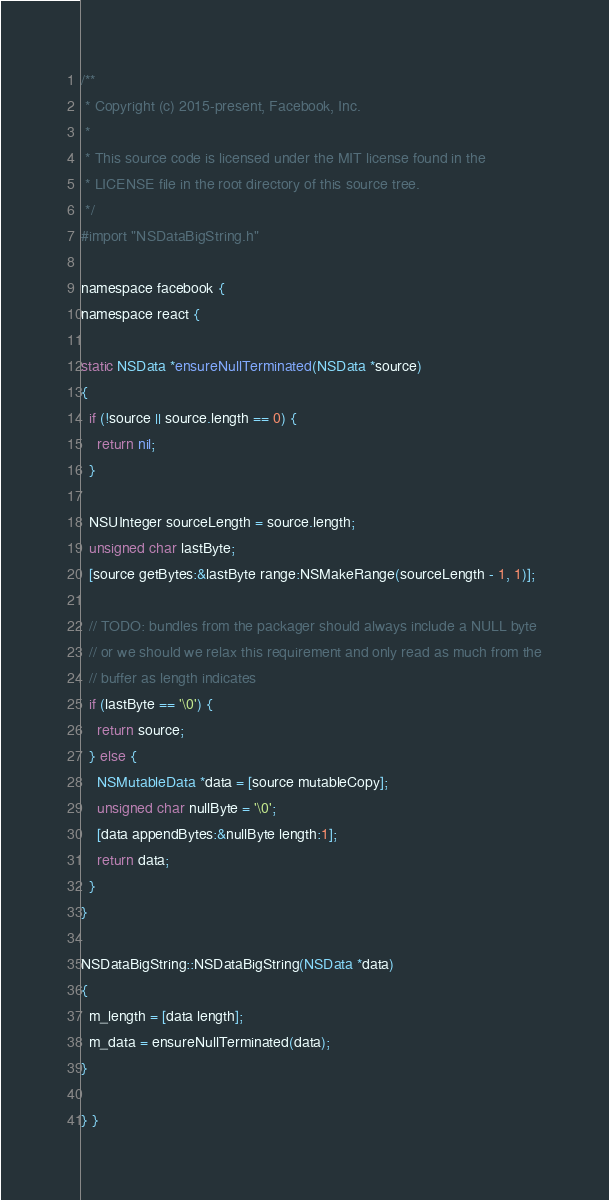<code> <loc_0><loc_0><loc_500><loc_500><_ObjectiveC_>/**
 * Copyright (c) 2015-present, Facebook, Inc.
 *
 * This source code is licensed under the MIT license found in the
 * LICENSE file in the root directory of this source tree.
 */
#import "NSDataBigString.h"

namespace facebook {
namespace react {

static NSData *ensureNullTerminated(NSData *source)
{
  if (!source || source.length == 0) {
    return nil;
  }

  NSUInteger sourceLength = source.length;
  unsigned char lastByte;
  [source getBytes:&lastByte range:NSMakeRange(sourceLength - 1, 1)];

  // TODO: bundles from the packager should always include a NULL byte
  // or we should we relax this requirement and only read as much from the
  // buffer as length indicates
  if (lastByte == '\0') {
    return source;
  } else {
    NSMutableData *data = [source mutableCopy];
    unsigned char nullByte = '\0';
    [data appendBytes:&nullByte length:1];
    return data;
  }
}

NSDataBigString::NSDataBigString(NSData *data)
{
  m_length = [data length];
  m_data = ensureNullTerminated(data);
}

} }
</code> 